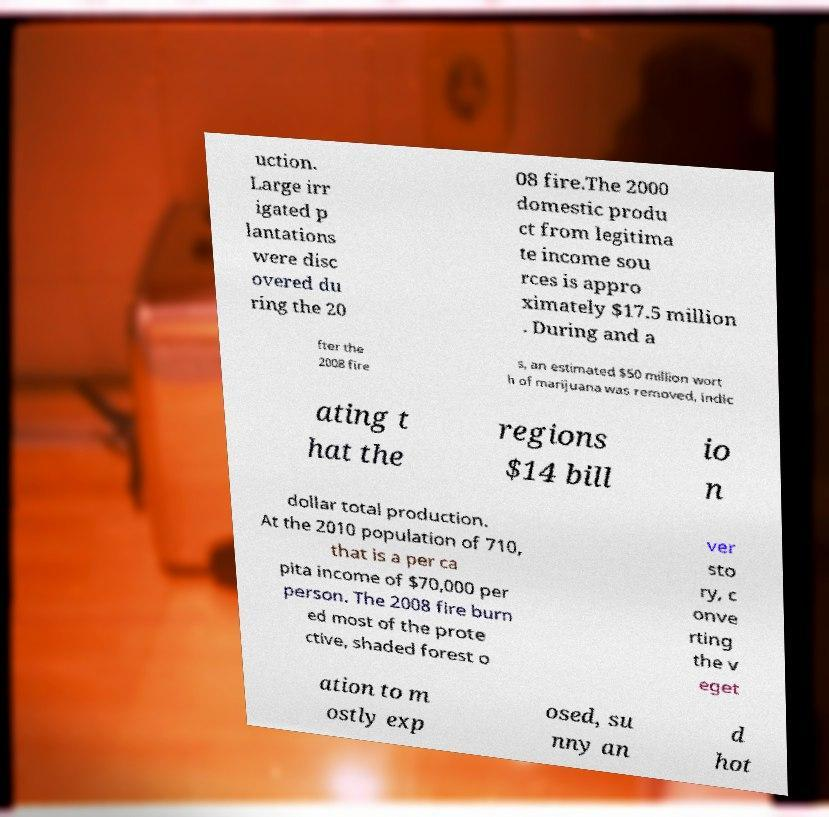For documentation purposes, I need the text within this image transcribed. Could you provide that? uction. Large irr igated p lantations were disc overed du ring the 20 08 fire.The 2000 domestic produ ct from legitima te income sou rces is appro ximately $17.5 million . During and a fter the 2008 fire s, an estimated $50 million wort h of marijuana was removed, indic ating t hat the regions $14 bill io n dollar total production. At the 2010 population of 710, that is a per ca pita income of $70,000 per person. The 2008 fire burn ed most of the prote ctive, shaded forest o ver sto ry, c onve rting the v eget ation to m ostly exp osed, su nny an d hot 